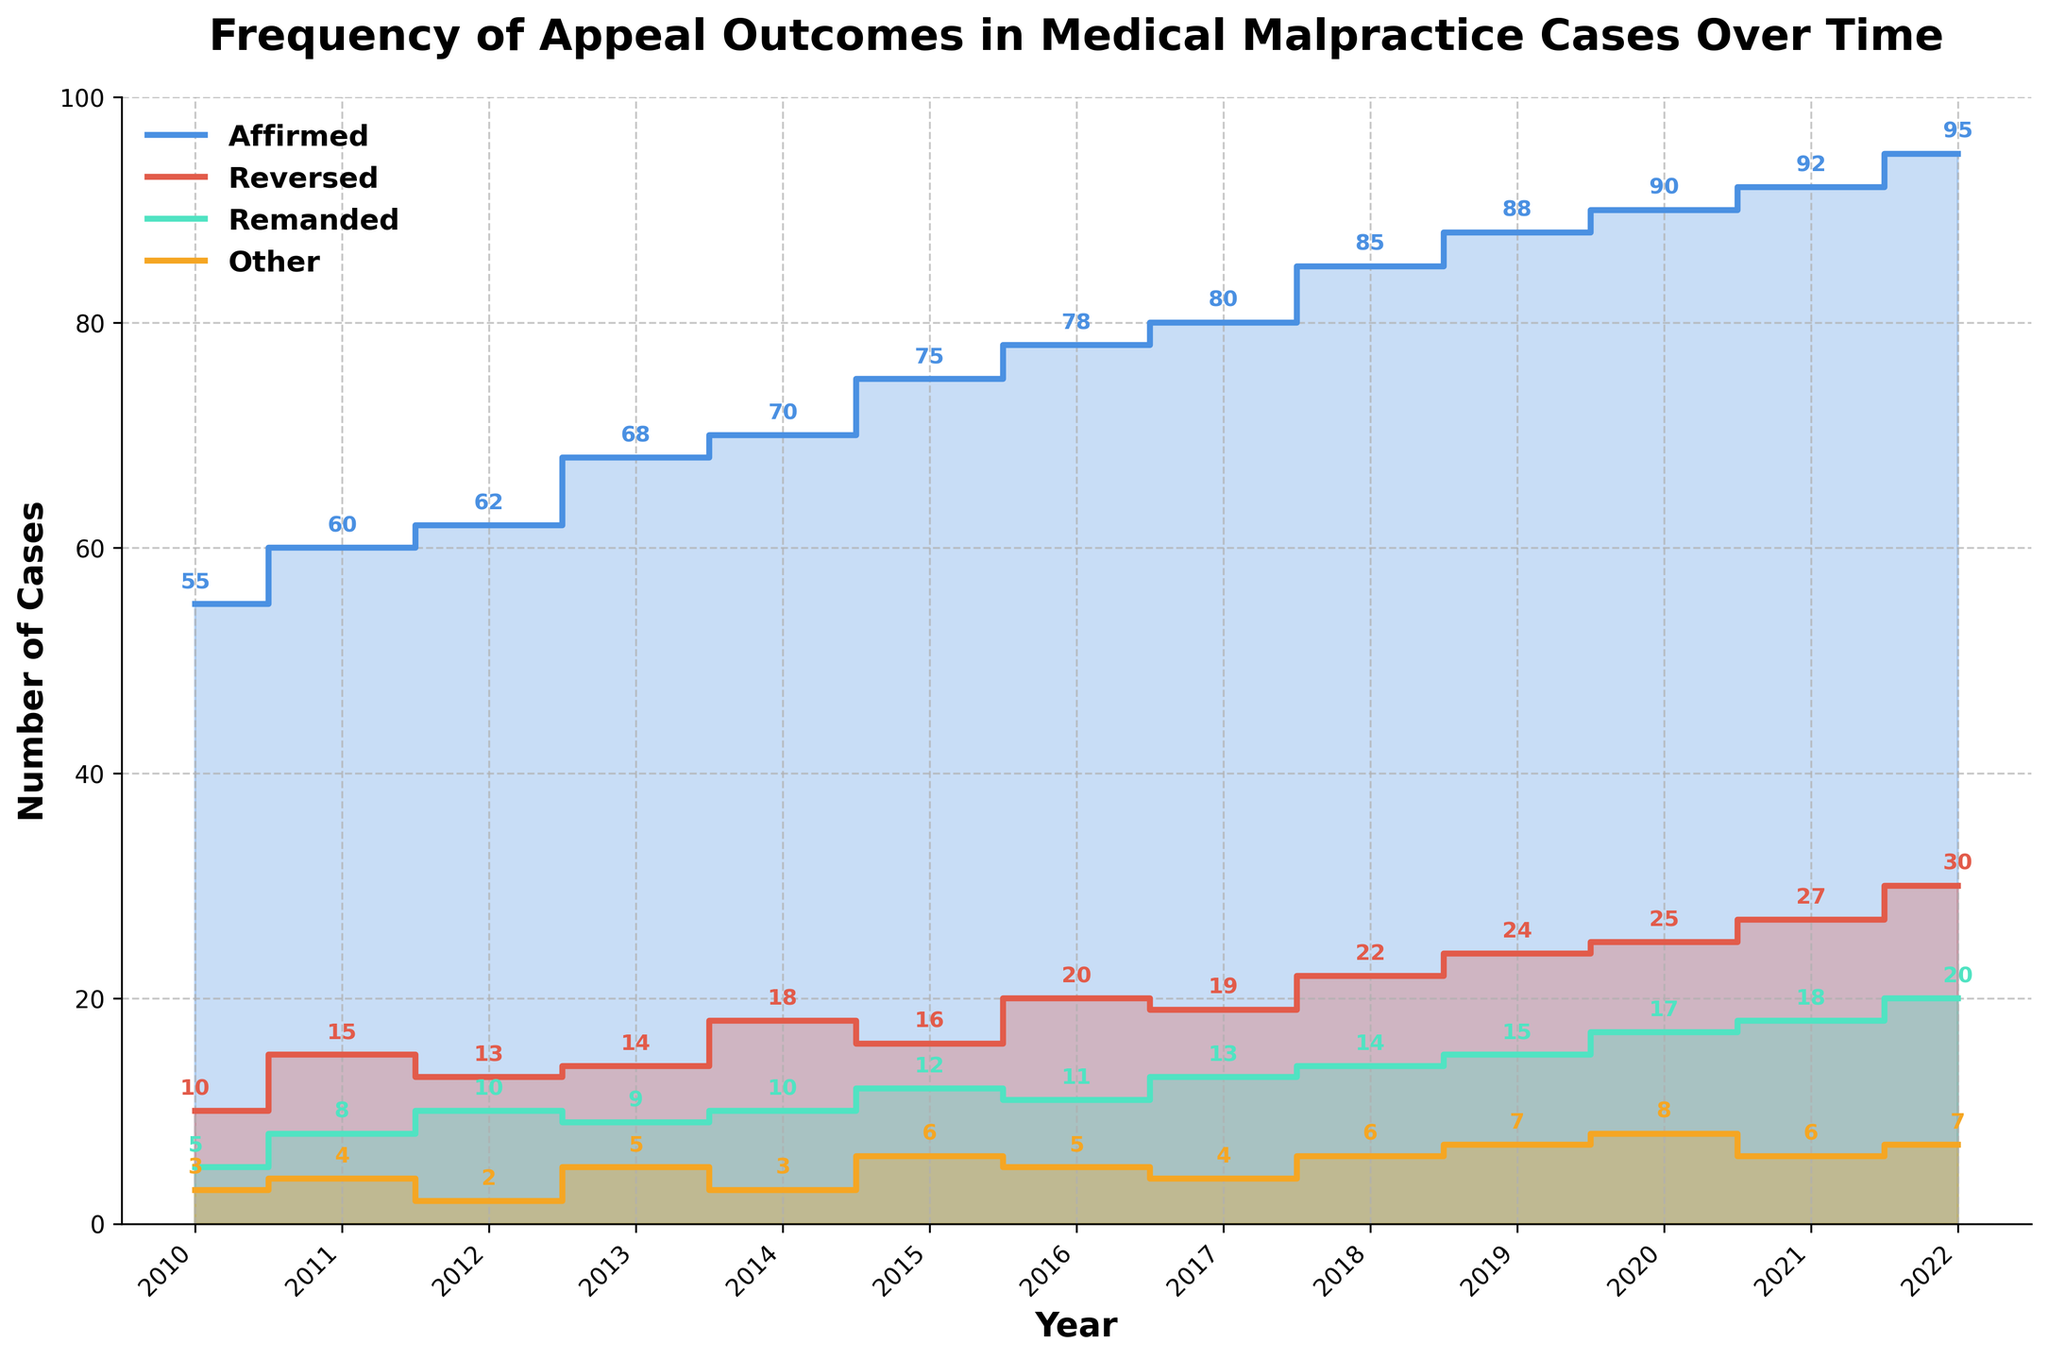What is the title of the figure? The title is usually displayed at the top of the figure. In this case, it is clearly mentioned there.
Answer: Frequency of Appeal Outcomes in Medical Malpractice Cases Over Time What color represents the "Affirmed" cases in the figure? The color representing "Affirmed" cases can be identified by matching the color of the corresponding line in the legend to the color of the actual line in the plot.
Answer: Blue Which year had the highest number of "Reversed" cases? To find this, look for the peak of the "Reversed" line, then trace it down to the corresponding year on the x-axis.
Answer: 2022 How many "Other" cases were there in 2018? Trace the line representing "Other" cases to the year 2018 on the x-axis, then read the value on the y-axis or the nearest data label.
Answer: 6 Between which years did the number of "Affirmed" cases increase the most? Examine the steps in the "Affirmed" line and identify the largest vertical increase between consecutive years.
Answer: 2018 and 2019 What's the total number of "Affirmed" cases in 2021 and 2022? Add the number of "Affirmed" cases for both 2021 and 2022. From the y-axis or data labels, these values are 92 and 95 respectively. 92 + 95 = 187
Answer: 187 Compare the trend of "Remanded" cases to "Reversed" cases over the years. What do you notice? Observe both the "Remanded" and "Reversed" lines throughout the period. The "Remanded" cases increase gradually while the "Reversed" cases show a more fluctuating increase.
Answer: "Remanded" cases increase steadily, whereas "Reversed" cases increase more variably Identify any year(s) where the number of "Other" cases decreased compared to the previous year. Track the "Other" line and find any descending steps. These are noticeable decreases.
Answer: 2012 and 2021 What's the average number of "Remanded" cases over the 13 years? Add up all the numbers for "Remanded" cases and divide by the number of years (13). (5+8+10+9+10+12+11+13+14+15+17+18+20)=162, 162/13 = 12.46
Answer: 12.46 Which category experienced the highest increase from 2019 to 2022? Compare the increase in numbers of each category from 2019 to 2022. "Affirmed" increased by 7 (95-88), "Reversed" by 6 (30-24), "Remanded" by 5 (20-15), "Other" by 0 (7-7). The highest increase is in the "Affirmed" category.
Answer: Affirmed 